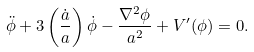Convert formula to latex. <formula><loc_0><loc_0><loc_500><loc_500>\ddot { \phi } + 3 \left ( \frac { \dot { a } } { a } \right ) \dot { \phi } - \frac { \nabla ^ { 2 } \phi } { a ^ { 2 } } + V ^ { \prime } ( \phi ) = 0 .</formula> 